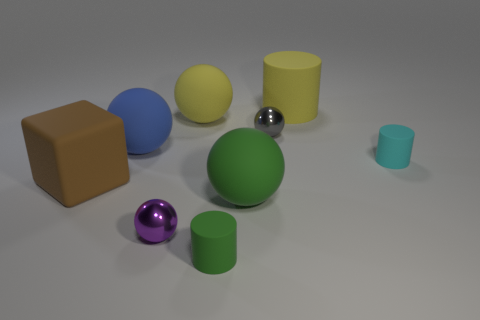Subtract 1 spheres. How many spheres are left? 4 Subtract all cylinders. How many objects are left? 6 Add 8 tiny cyan rubber balls. How many tiny cyan rubber balls exist? 8 Subtract 0 gray cubes. How many objects are left? 9 Subtract all large blue matte objects. Subtract all green cylinders. How many objects are left? 7 Add 6 large cylinders. How many large cylinders are left? 7 